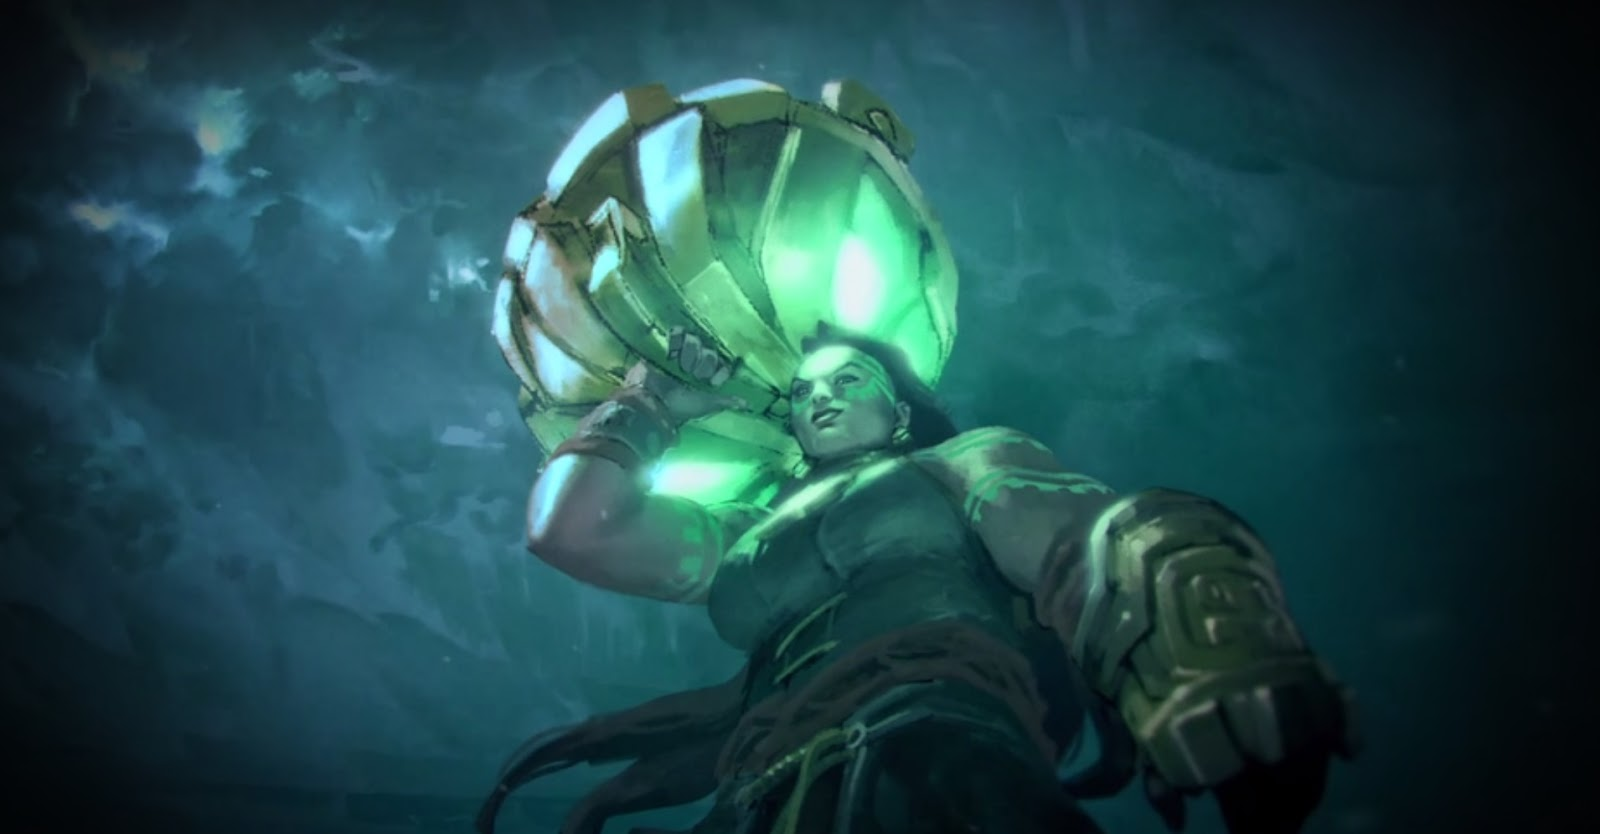Can you speculate on the potential dangers this character might face during such a mission? During a high-risk underwater mission such as this, the character could face numerous dangers. The immense water pressure at great depths poses a significant threat, potentially compromising the integrity of the suit. Encounters with aggressive marine life, unexpected geological shifts causing underwater landslides or quakes, and even the failure of critical suit systems like oxygen supply or navigation aids increase the peril. Furthermore, if the mission has a military aspect, threats could include encounters with enemy combatants or dangerous underwater mines. 